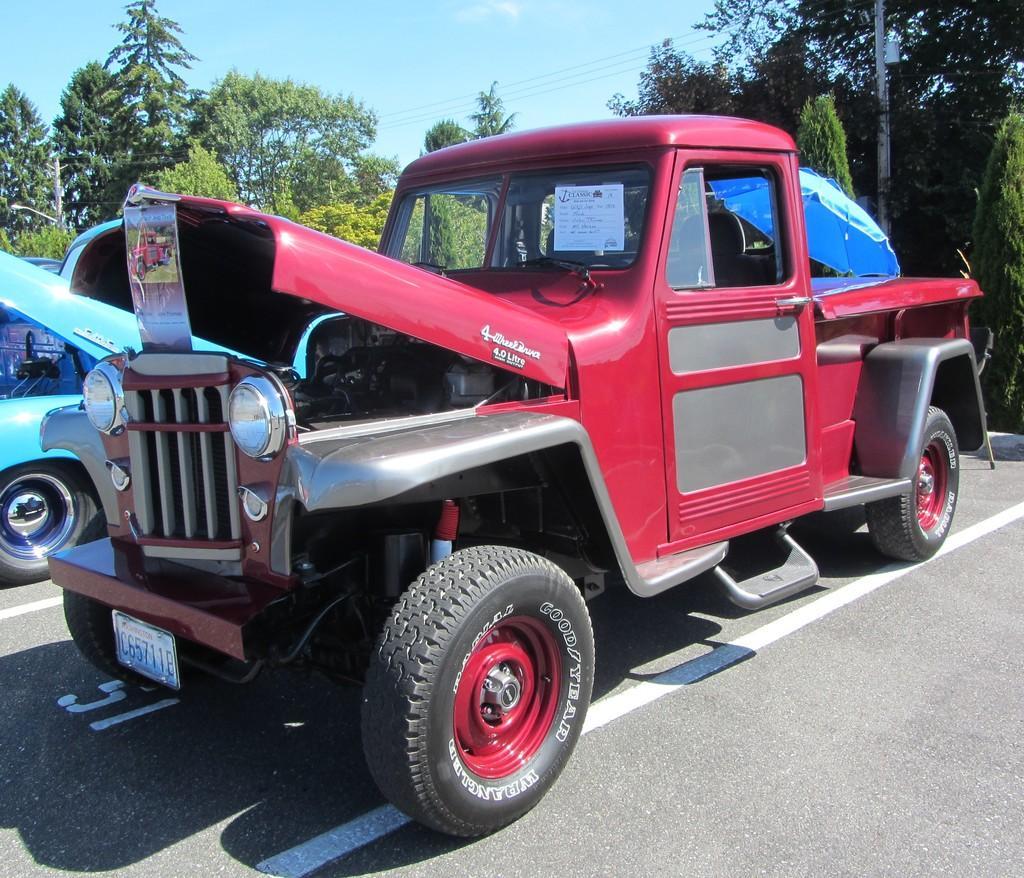Can you describe this image briefly? There is a vehicle with a number plate, poster and an umbrella on that. In the back there are trees and sky. Also there is another vehicle and there is road. 